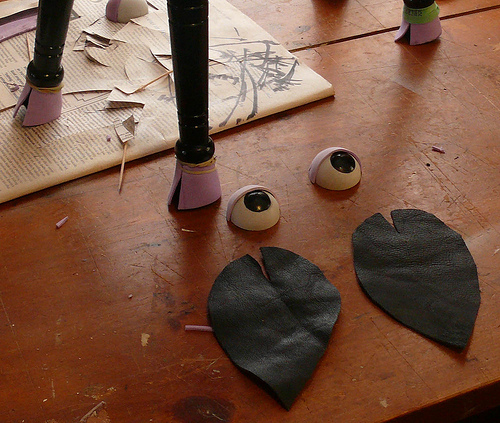<image>
Is there a eye ball in front of the news paper? Yes. The eye ball is positioned in front of the news paper, appearing closer to the camera viewpoint. 